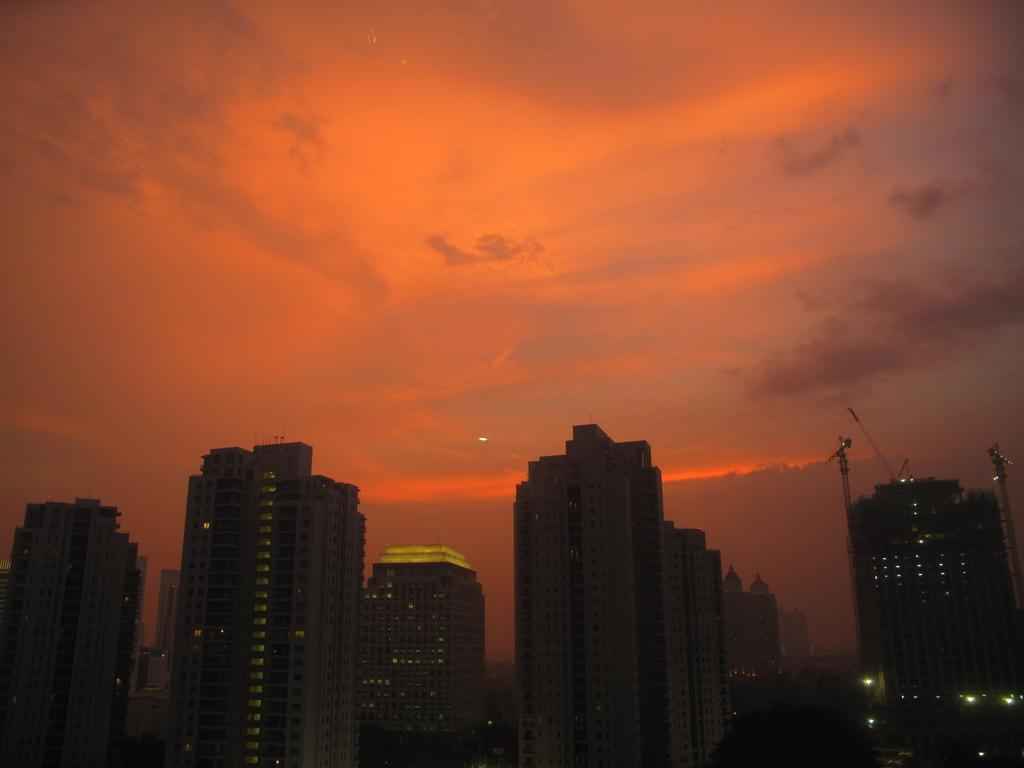What type of structures can be seen in the image? There are buildings in the image. What can be seen illuminating the scene in the image? There are lights visible in the image. What else is present in the image besides buildings and lights? There are objects in the image. What is visible in the background of the image? The sky is visible in the background of the image. What can be observed in the sky in the image? Clouds are present in the sky. Can you tell me how many wings are visible on the buildings in the image? There are no wings present on the buildings in the image; they are architectural structures without wings. 